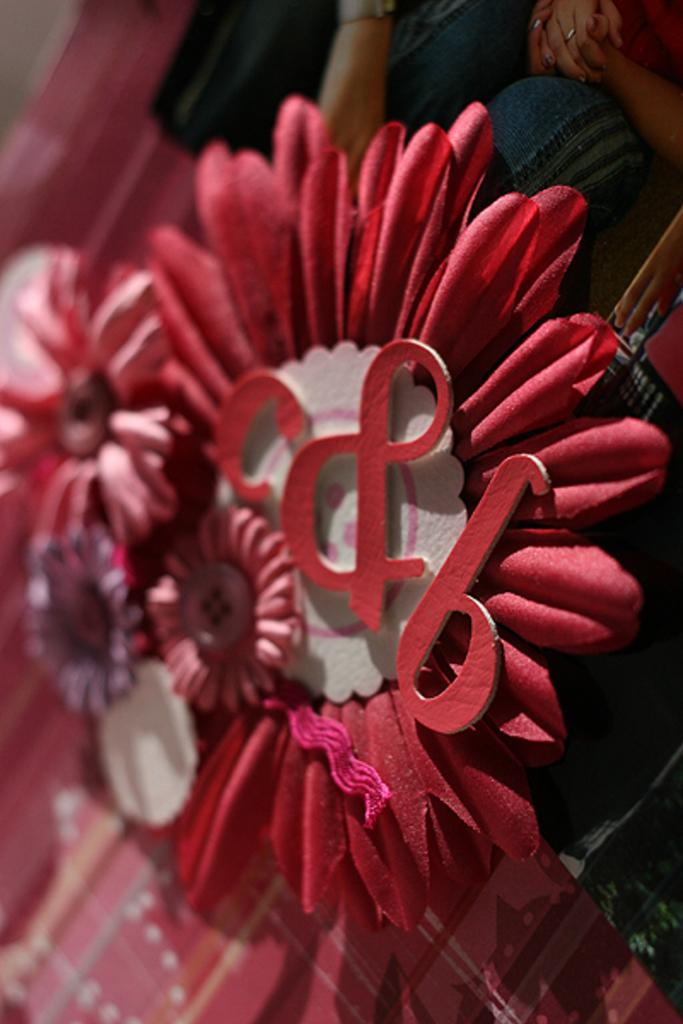What type of decorative items are in the image? There are artificial flowers in the image. What is unique about these artificial flowers? The artificial flowers have text on them. Where are the artificial flowers placed? The artificial flowers are placed on a surface. What can be seen at the top of the image? There is a picture of a man and woman at the top of the image. How many rabbits can be seen interacting with the artificial flowers in the image? There are no rabbits present in the image; it features artificial flowers with text on them. What type of wave is depicted in the image? There is no wave depicted in the image; it features artificial flowers, text, and a picture of a man and woman. 